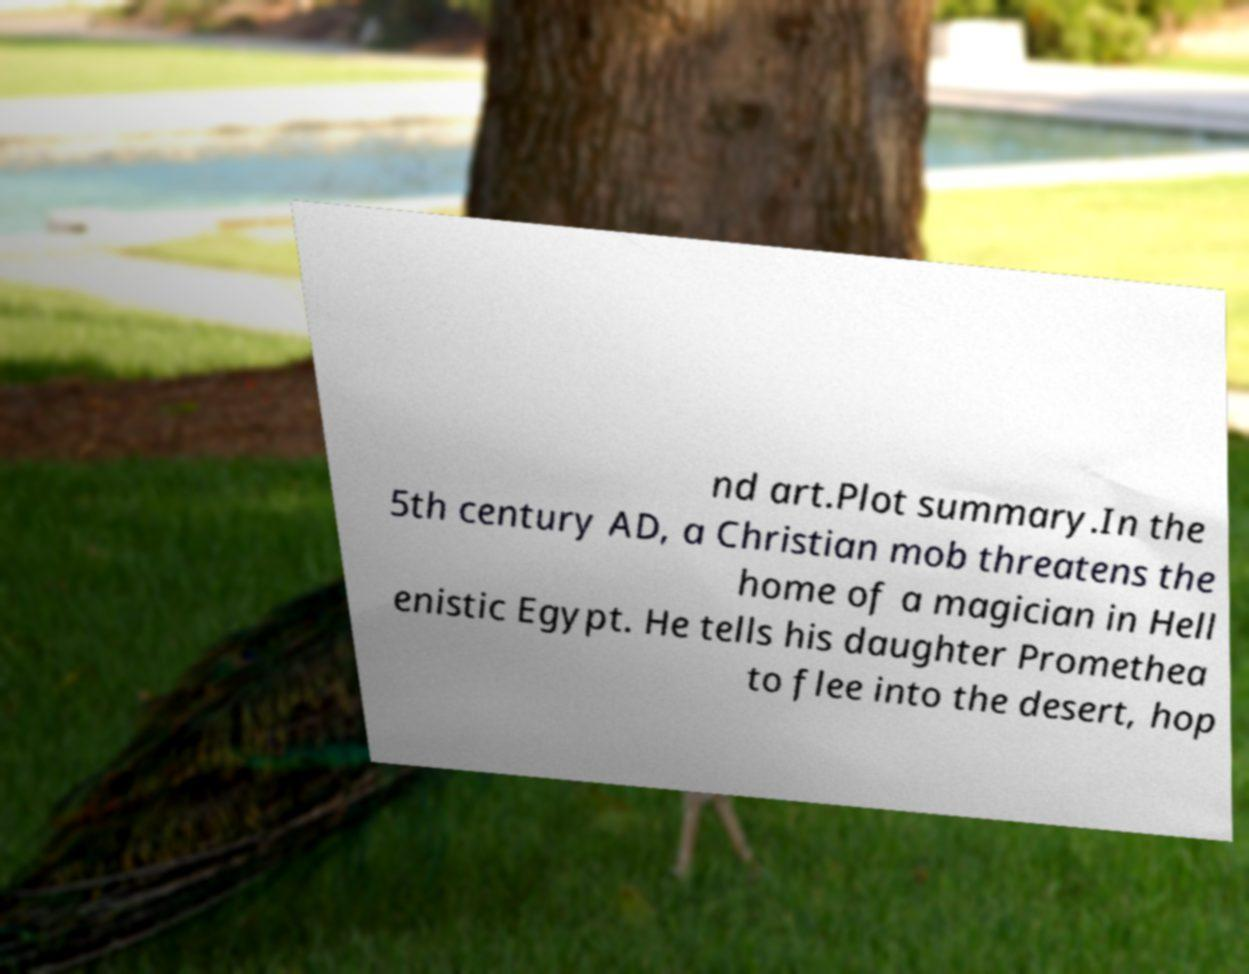For documentation purposes, I need the text within this image transcribed. Could you provide that? nd art.Plot summary.In the 5th century AD, a Christian mob threatens the home of a magician in Hell enistic Egypt. He tells his daughter Promethea to flee into the desert, hop 